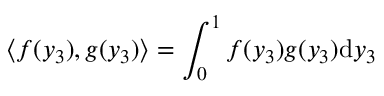<formula> <loc_0><loc_0><loc_500><loc_500>\left \langle f ( y _ { 3 } ) , g ( y _ { 3 } ) \right \rangle = \int _ { 0 } ^ { 1 } f ( y _ { 3 } ) g ( y _ { 3 } ) d y _ { 3 }</formula> 